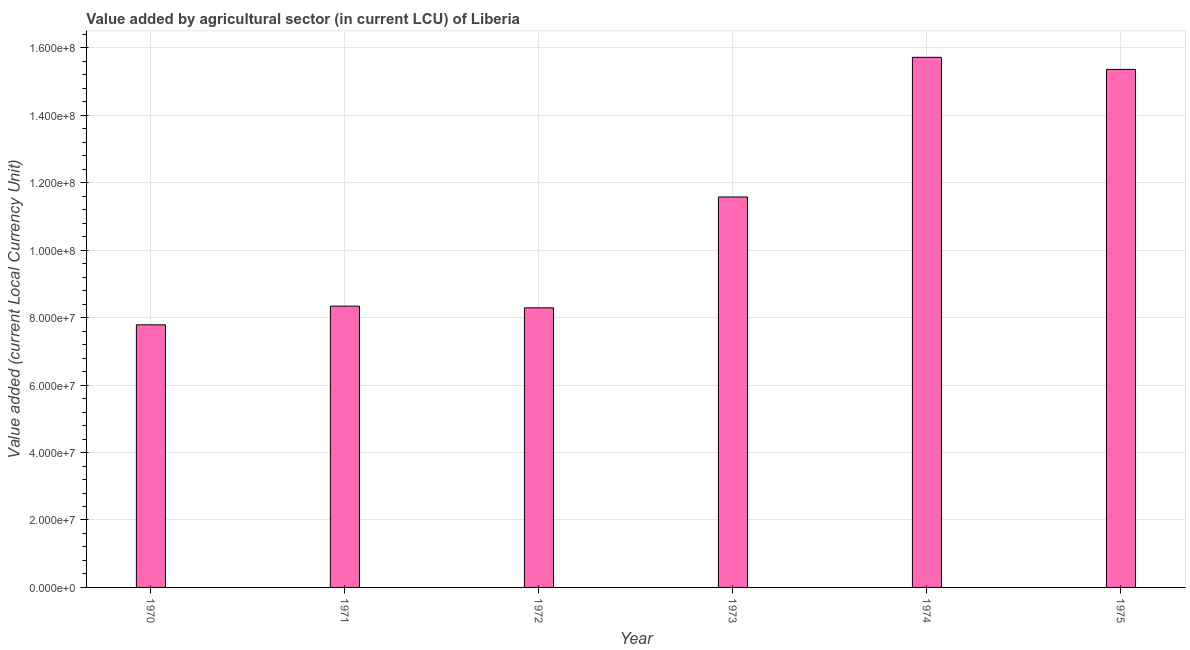Does the graph contain any zero values?
Your answer should be compact. No. Does the graph contain grids?
Ensure brevity in your answer.  Yes. What is the title of the graph?
Keep it short and to the point. Value added by agricultural sector (in current LCU) of Liberia. What is the label or title of the Y-axis?
Provide a succinct answer. Value added (current Local Currency Unit). What is the value added by agriculture sector in 1971?
Offer a terse response. 8.34e+07. Across all years, what is the maximum value added by agriculture sector?
Keep it short and to the point. 1.57e+08. Across all years, what is the minimum value added by agriculture sector?
Your answer should be compact. 7.79e+07. In which year was the value added by agriculture sector maximum?
Give a very brief answer. 1974. In which year was the value added by agriculture sector minimum?
Make the answer very short. 1970. What is the sum of the value added by agriculture sector?
Offer a very short reply. 6.71e+08. What is the difference between the value added by agriculture sector in 1971 and 1974?
Ensure brevity in your answer.  -7.38e+07. What is the average value added by agriculture sector per year?
Keep it short and to the point. 1.12e+08. What is the median value added by agriculture sector?
Provide a short and direct response. 9.96e+07. Do a majority of the years between 1973 and 1970 (inclusive) have value added by agriculture sector greater than 36000000 LCU?
Provide a short and direct response. Yes. What is the ratio of the value added by agriculture sector in 1970 to that in 1971?
Your answer should be compact. 0.93. Is the difference between the value added by agriculture sector in 1972 and 1974 greater than the difference between any two years?
Your answer should be very brief. No. What is the difference between the highest and the second highest value added by agriculture sector?
Your answer should be compact. 3.59e+06. What is the difference between the highest and the lowest value added by agriculture sector?
Give a very brief answer. 7.93e+07. In how many years, is the value added by agriculture sector greater than the average value added by agriculture sector taken over all years?
Your response must be concise. 3. Are all the bars in the graph horizontal?
Give a very brief answer. No. What is the difference between two consecutive major ticks on the Y-axis?
Offer a terse response. 2.00e+07. Are the values on the major ticks of Y-axis written in scientific E-notation?
Your response must be concise. Yes. What is the Value added (current Local Currency Unit) in 1970?
Provide a short and direct response. 7.79e+07. What is the Value added (current Local Currency Unit) of 1971?
Provide a succinct answer. 8.34e+07. What is the Value added (current Local Currency Unit) in 1972?
Provide a succinct answer. 8.29e+07. What is the Value added (current Local Currency Unit) in 1973?
Ensure brevity in your answer.  1.16e+08. What is the Value added (current Local Currency Unit) of 1974?
Make the answer very short. 1.57e+08. What is the Value added (current Local Currency Unit) in 1975?
Your answer should be very brief. 1.54e+08. What is the difference between the Value added (current Local Currency Unit) in 1970 and 1971?
Your answer should be very brief. -5.55e+06. What is the difference between the Value added (current Local Currency Unit) in 1970 and 1972?
Provide a short and direct response. -5.04e+06. What is the difference between the Value added (current Local Currency Unit) in 1970 and 1973?
Ensure brevity in your answer.  -3.79e+07. What is the difference between the Value added (current Local Currency Unit) in 1970 and 1974?
Ensure brevity in your answer.  -7.93e+07. What is the difference between the Value added (current Local Currency Unit) in 1970 and 1975?
Provide a short and direct response. -7.57e+07. What is the difference between the Value added (current Local Currency Unit) in 1971 and 1972?
Offer a very short reply. 5.12e+05. What is the difference between the Value added (current Local Currency Unit) in 1971 and 1973?
Provide a short and direct response. -3.24e+07. What is the difference between the Value added (current Local Currency Unit) in 1971 and 1974?
Give a very brief answer. -7.38e+07. What is the difference between the Value added (current Local Currency Unit) in 1971 and 1975?
Ensure brevity in your answer.  -7.02e+07. What is the difference between the Value added (current Local Currency Unit) in 1972 and 1973?
Your response must be concise. -3.29e+07. What is the difference between the Value added (current Local Currency Unit) in 1972 and 1974?
Provide a short and direct response. -7.43e+07. What is the difference between the Value added (current Local Currency Unit) in 1972 and 1975?
Your response must be concise. -7.07e+07. What is the difference between the Value added (current Local Currency Unit) in 1973 and 1974?
Keep it short and to the point. -4.14e+07. What is the difference between the Value added (current Local Currency Unit) in 1973 and 1975?
Offer a very short reply. -3.78e+07. What is the difference between the Value added (current Local Currency Unit) in 1974 and 1975?
Provide a succinct answer. 3.59e+06. What is the ratio of the Value added (current Local Currency Unit) in 1970 to that in 1971?
Your response must be concise. 0.93. What is the ratio of the Value added (current Local Currency Unit) in 1970 to that in 1972?
Ensure brevity in your answer.  0.94. What is the ratio of the Value added (current Local Currency Unit) in 1970 to that in 1973?
Give a very brief answer. 0.67. What is the ratio of the Value added (current Local Currency Unit) in 1970 to that in 1974?
Keep it short and to the point. 0.49. What is the ratio of the Value added (current Local Currency Unit) in 1970 to that in 1975?
Your answer should be compact. 0.51. What is the ratio of the Value added (current Local Currency Unit) in 1971 to that in 1972?
Offer a very short reply. 1.01. What is the ratio of the Value added (current Local Currency Unit) in 1971 to that in 1973?
Give a very brief answer. 0.72. What is the ratio of the Value added (current Local Currency Unit) in 1971 to that in 1974?
Keep it short and to the point. 0.53. What is the ratio of the Value added (current Local Currency Unit) in 1971 to that in 1975?
Ensure brevity in your answer.  0.54. What is the ratio of the Value added (current Local Currency Unit) in 1972 to that in 1973?
Your answer should be very brief. 0.72. What is the ratio of the Value added (current Local Currency Unit) in 1972 to that in 1974?
Offer a terse response. 0.53. What is the ratio of the Value added (current Local Currency Unit) in 1972 to that in 1975?
Offer a terse response. 0.54. What is the ratio of the Value added (current Local Currency Unit) in 1973 to that in 1974?
Keep it short and to the point. 0.74. What is the ratio of the Value added (current Local Currency Unit) in 1973 to that in 1975?
Provide a succinct answer. 0.75. What is the ratio of the Value added (current Local Currency Unit) in 1974 to that in 1975?
Keep it short and to the point. 1.02. 